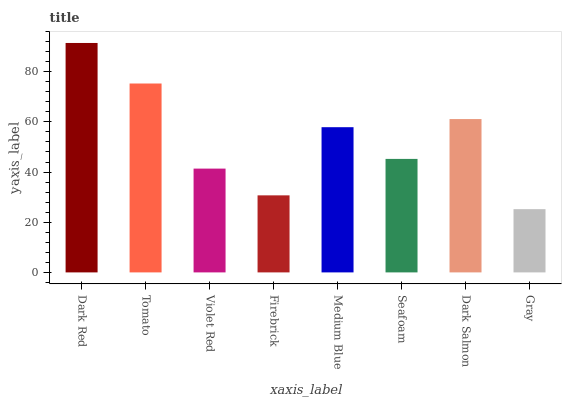Is Gray the minimum?
Answer yes or no. Yes. Is Dark Red the maximum?
Answer yes or no. Yes. Is Tomato the minimum?
Answer yes or no. No. Is Tomato the maximum?
Answer yes or no. No. Is Dark Red greater than Tomato?
Answer yes or no. Yes. Is Tomato less than Dark Red?
Answer yes or no. Yes. Is Tomato greater than Dark Red?
Answer yes or no. No. Is Dark Red less than Tomato?
Answer yes or no. No. Is Medium Blue the high median?
Answer yes or no. Yes. Is Seafoam the low median?
Answer yes or no. Yes. Is Firebrick the high median?
Answer yes or no. No. Is Gray the low median?
Answer yes or no. No. 